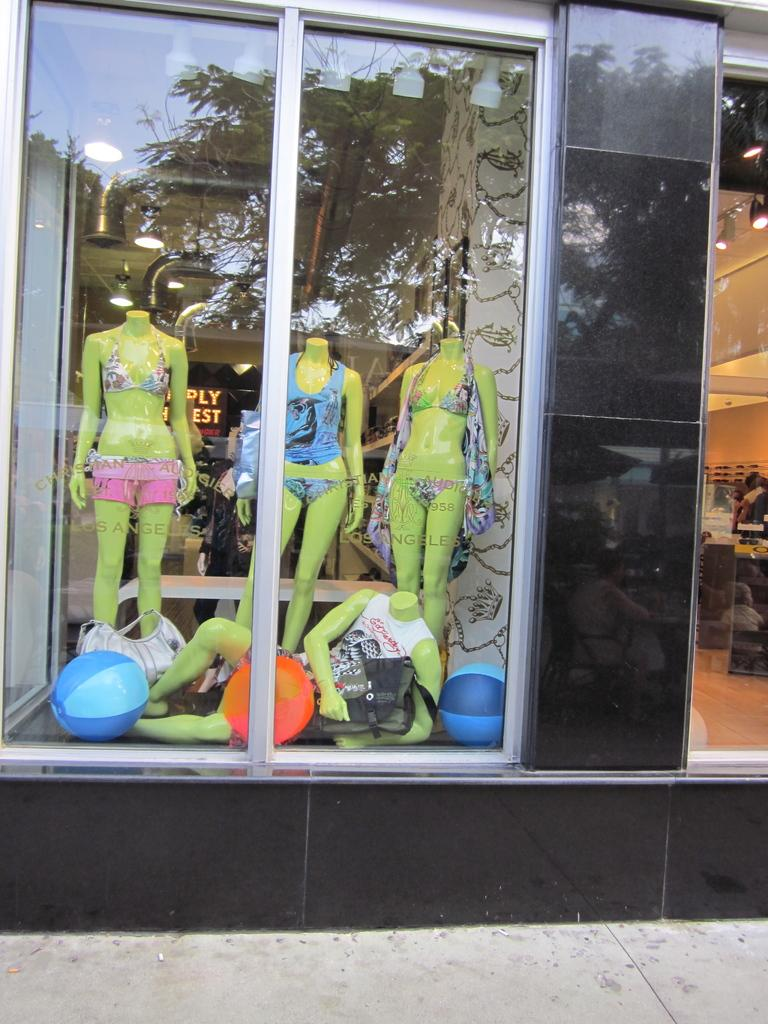What type of figures can be seen in the image? There are mannequins in the image. What objects are near the mannequins? There are balls and bags near the mannequins. What can be seen illuminating the scene in the image? There are lights in the image. What architectural feature is present in the image? There are pipes to the ceiling in the image. What type of country is depicted in the image? There is no country depicted in the image; it features mannequins, balls, bags, lights, and pipes. How many wheels can be seen in the image? There are no wheels present in the image. 